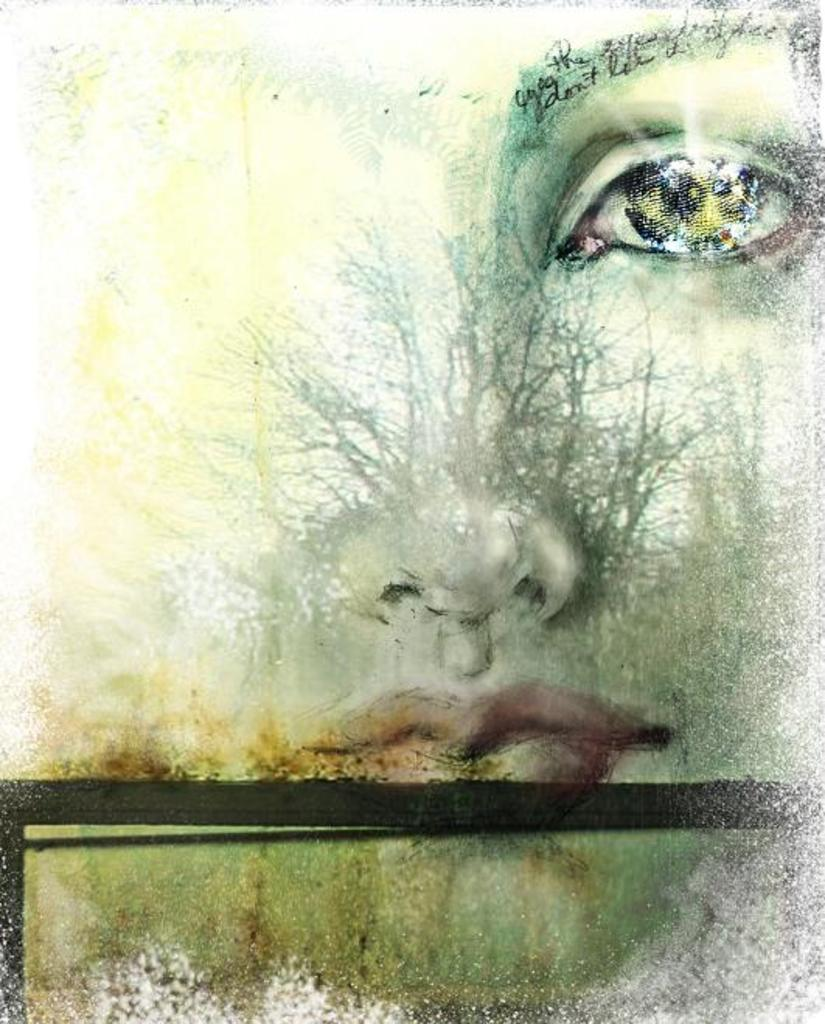What is the main subject of the picture? The main subject of the picture is an art piece. What does the art piece depict? The art piece depicts a human face. What facial features can be seen on the human face? The human face has eyes, a nose, and lips. How many pears are present in the image? There are no pears present in the image; it features an art piece depicting a human face. What type of journey is the human face taking in the image? The human face is not taking any journey in the image; it is a static representation in an art piece. 